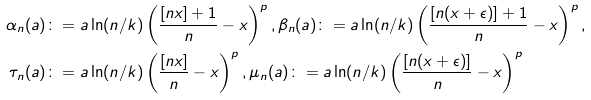Convert formula to latex. <formula><loc_0><loc_0><loc_500><loc_500>\alpha _ { n } ( a ) & \colon = a \ln ( n / k ) \left ( \frac { [ n x ] + 1 } { n } - x \right ) ^ { p } , \beta _ { n } ( a ) \colon = a \ln ( n / k ) \left ( \frac { [ n ( x + \epsilon ) ] + 1 } { n } - x \right ) ^ { p } , \\ \tau _ { n } ( a ) & \colon = a \ln ( n / k ) \left ( \frac { [ n x ] } { n } - x \right ) ^ { p } , \mu _ { n } ( a ) \colon = a \ln ( n / k ) \left ( \frac { [ n ( x + \epsilon ) ] } { n } - x \right ) ^ { p }</formula> 